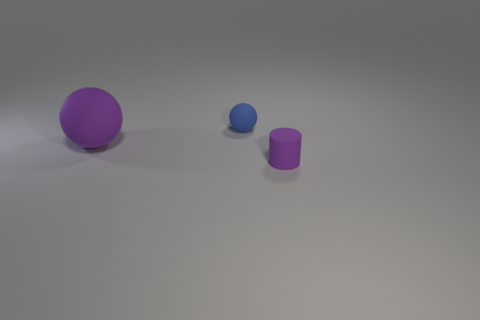How many other blue matte balls are the same size as the blue rubber sphere?
Your answer should be compact. 0. There is a matte thing that is the same color as the big ball; what shape is it?
Your answer should be very brief. Cylinder. Are there any small purple objects that are to the left of the thing right of the tiny rubber sphere?
Ensure brevity in your answer.  No. What number of things are small objects behind the purple matte sphere or blue metallic objects?
Your answer should be very brief. 1. How many gray matte blocks are there?
Your answer should be compact. 0. There is a small thing that is the same material as the purple cylinder; what is its shape?
Keep it short and to the point. Sphere. How big is the purple thing left of the thing to the right of the blue object?
Your response must be concise. Large. What number of objects are either purple matte objects that are behind the purple cylinder or rubber objects that are right of the large rubber ball?
Provide a succinct answer. 3. Are there fewer big brown things than small objects?
Ensure brevity in your answer.  Yes. What number of things are either purple objects or blue spheres?
Your response must be concise. 3. 